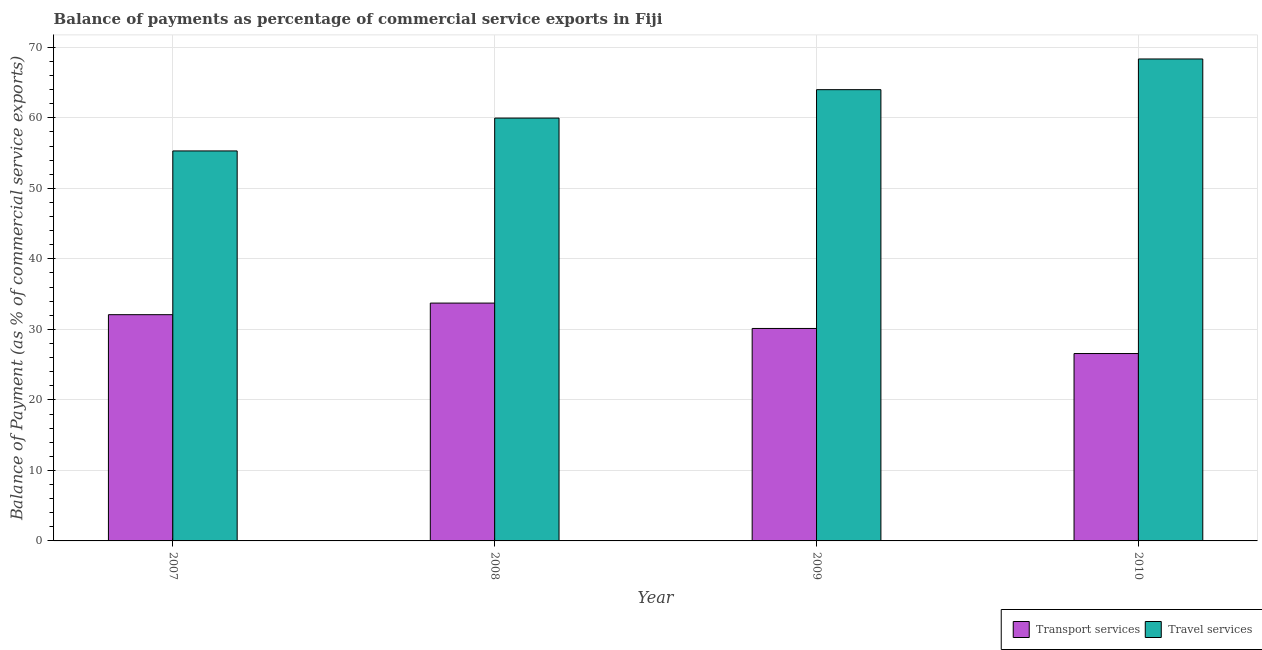How many groups of bars are there?
Your answer should be very brief. 4. Are the number of bars per tick equal to the number of legend labels?
Ensure brevity in your answer.  Yes. How many bars are there on the 3rd tick from the left?
Provide a succinct answer. 2. How many bars are there on the 3rd tick from the right?
Provide a succinct answer. 2. What is the balance of payments of travel services in 2009?
Offer a terse response. 64. Across all years, what is the maximum balance of payments of travel services?
Provide a short and direct response. 68.36. Across all years, what is the minimum balance of payments of transport services?
Give a very brief answer. 26.58. In which year was the balance of payments of travel services minimum?
Your answer should be very brief. 2007. What is the total balance of payments of travel services in the graph?
Your response must be concise. 247.64. What is the difference between the balance of payments of travel services in 2007 and that in 2009?
Keep it short and to the point. -8.69. What is the difference between the balance of payments of transport services in 2008 and the balance of payments of travel services in 2009?
Ensure brevity in your answer.  3.6. What is the average balance of payments of travel services per year?
Offer a very short reply. 61.91. What is the ratio of the balance of payments of travel services in 2008 to that in 2009?
Offer a terse response. 0.94. Is the difference between the balance of payments of transport services in 2009 and 2010 greater than the difference between the balance of payments of travel services in 2009 and 2010?
Offer a terse response. No. What is the difference between the highest and the second highest balance of payments of travel services?
Offer a terse response. 4.35. What is the difference between the highest and the lowest balance of payments of transport services?
Offer a very short reply. 7.16. In how many years, is the balance of payments of transport services greater than the average balance of payments of transport services taken over all years?
Your response must be concise. 2. What does the 2nd bar from the left in 2010 represents?
Your response must be concise. Travel services. What does the 2nd bar from the right in 2007 represents?
Your answer should be very brief. Transport services. How many years are there in the graph?
Keep it short and to the point. 4. Are the values on the major ticks of Y-axis written in scientific E-notation?
Give a very brief answer. No. Does the graph contain grids?
Your answer should be very brief. Yes. Where does the legend appear in the graph?
Make the answer very short. Bottom right. How many legend labels are there?
Your answer should be compact. 2. How are the legend labels stacked?
Ensure brevity in your answer.  Horizontal. What is the title of the graph?
Offer a terse response. Balance of payments as percentage of commercial service exports in Fiji. Does "Canada" appear as one of the legend labels in the graph?
Your answer should be very brief. No. What is the label or title of the X-axis?
Ensure brevity in your answer.  Year. What is the label or title of the Y-axis?
Your response must be concise. Balance of Payment (as % of commercial service exports). What is the Balance of Payment (as % of commercial service exports) in Transport services in 2007?
Your answer should be very brief. 32.09. What is the Balance of Payment (as % of commercial service exports) in Travel services in 2007?
Your response must be concise. 55.31. What is the Balance of Payment (as % of commercial service exports) in Transport services in 2008?
Make the answer very short. 33.73. What is the Balance of Payment (as % of commercial service exports) of Travel services in 2008?
Keep it short and to the point. 59.97. What is the Balance of Payment (as % of commercial service exports) of Transport services in 2009?
Give a very brief answer. 30.13. What is the Balance of Payment (as % of commercial service exports) in Travel services in 2009?
Provide a succinct answer. 64. What is the Balance of Payment (as % of commercial service exports) in Transport services in 2010?
Ensure brevity in your answer.  26.58. What is the Balance of Payment (as % of commercial service exports) in Travel services in 2010?
Ensure brevity in your answer.  68.36. Across all years, what is the maximum Balance of Payment (as % of commercial service exports) in Transport services?
Offer a terse response. 33.73. Across all years, what is the maximum Balance of Payment (as % of commercial service exports) of Travel services?
Your answer should be compact. 68.36. Across all years, what is the minimum Balance of Payment (as % of commercial service exports) of Transport services?
Keep it short and to the point. 26.58. Across all years, what is the minimum Balance of Payment (as % of commercial service exports) of Travel services?
Offer a very short reply. 55.31. What is the total Balance of Payment (as % of commercial service exports) of Transport services in the graph?
Ensure brevity in your answer.  122.53. What is the total Balance of Payment (as % of commercial service exports) of Travel services in the graph?
Give a very brief answer. 247.64. What is the difference between the Balance of Payment (as % of commercial service exports) of Transport services in 2007 and that in 2008?
Offer a terse response. -1.64. What is the difference between the Balance of Payment (as % of commercial service exports) of Travel services in 2007 and that in 2008?
Make the answer very short. -4.66. What is the difference between the Balance of Payment (as % of commercial service exports) of Transport services in 2007 and that in 2009?
Ensure brevity in your answer.  1.96. What is the difference between the Balance of Payment (as % of commercial service exports) of Travel services in 2007 and that in 2009?
Provide a short and direct response. -8.69. What is the difference between the Balance of Payment (as % of commercial service exports) of Transport services in 2007 and that in 2010?
Give a very brief answer. 5.51. What is the difference between the Balance of Payment (as % of commercial service exports) of Travel services in 2007 and that in 2010?
Provide a short and direct response. -13.04. What is the difference between the Balance of Payment (as % of commercial service exports) in Transport services in 2008 and that in 2009?
Offer a very short reply. 3.6. What is the difference between the Balance of Payment (as % of commercial service exports) in Travel services in 2008 and that in 2009?
Ensure brevity in your answer.  -4.03. What is the difference between the Balance of Payment (as % of commercial service exports) of Transport services in 2008 and that in 2010?
Provide a succinct answer. 7.16. What is the difference between the Balance of Payment (as % of commercial service exports) in Travel services in 2008 and that in 2010?
Offer a terse response. -8.38. What is the difference between the Balance of Payment (as % of commercial service exports) of Transport services in 2009 and that in 2010?
Make the answer very short. 3.56. What is the difference between the Balance of Payment (as % of commercial service exports) of Travel services in 2009 and that in 2010?
Keep it short and to the point. -4.35. What is the difference between the Balance of Payment (as % of commercial service exports) of Transport services in 2007 and the Balance of Payment (as % of commercial service exports) of Travel services in 2008?
Offer a very short reply. -27.88. What is the difference between the Balance of Payment (as % of commercial service exports) in Transport services in 2007 and the Balance of Payment (as % of commercial service exports) in Travel services in 2009?
Make the answer very short. -31.91. What is the difference between the Balance of Payment (as % of commercial service exports) in Transport services in 2007 and the Balance of Payment (as % of commercial service exports) in Travel services in 2010?
Provide a succinct answer. -36.27. What is the difference between the Balance of Payment (as % of commercial service exports) of Transport services in 2008 and the Balance of Payment (as % of commercial service exports) of Travel services in 2009?
Make the answer very short. -30.27. What is the difference between the Balance of Payment (as % of commercial service exports) of Transport services in 2008 and the Balance of Payment (as % of commercial service exports) of Travel services in 2010?
Make the answer very short. -34.62. What is the difference between the Balance of Payment (as % of commercial service exports) in Transport services in 2009 and the Balance of Payment (as % of commercial service exports) in Travel services in 2010?
Keep it short and to the point. -38.22. What is the average Balance of Payment (as % of commercial service exports) in Transport services per year?
Offer a terse response. 30.63. What is the average Balance of Payment (as % of commercial service exports) in Travel services per year?
Offer a terse response. 61.91. In the year 2007, what is the difference between the Balance of Payment (as % of commercial service exports) in Transport services and Balance of Payment (as % of commercial service exports) in Travel services?
Give a very brief answer. -23.22. In the year 2008, what is the difference between the Balance of Payment (as % of commercial service exports) in Transport services and Balance of Payment (as % of commercial service exports) in Travel services?
Offer a terse response. -26.24. In the year 2009, what is the difference between the Balance of Payment (as % of commercial service exports) of Transport services and Balance of Payment (as % of commercial service exports) of Travel services?
Ensure brevity in your answer.  -33.87. In the year 2010, what is the difference between the Balance of Payment (as % of commercial service exports) of Transport services and Balance of Payment (as % of commercial service exports) of Travel services?
Offer a terse response. -41.78. What is the ratio of the Balance of Payment (as % of commercial service exports) in Transport services in 2007 to that in 2008?
Keep it short and to the point. 0.95. What is the ratio of the Balance of Payment (as % of commercial service exports) of Travel services in 2007 to that in 2008?
Keep it short and to the point. 0.92. What is the ratio of the Balance of Payment (as % of commercial service exports) in Transport services in 2007 to that in 2009?
Make the answer very short. 1.06. What is the ratio of the Balance of Payment (as % of commercial service exports) of Travel services in 2007 to that in 2009?
Offer a very short reply. 0.86. What is the ratio of the Balance of Payment (as % of commercial service exports) in Transport services in 2007 to that in 2010?
Your response must be concise. 1.21. What is the ratio of the Balance of Payment (as % of commercial service exports) in Travel services in 2007 to that in 2010?
Make the answer very short. 0.81. What is the ratio of the Balance of Payment (as % of commercial service exports) of Transport services in 2008 to that in 2009?
Make the answer very short. 1.12. What is the ratio of the Balance of Payment (as % of commercial service exports) in Travel services in 2008 to that in 2009?
Provide a short and direct response. 0.94. What is the ratio of the Balance of Payment (as % of commercial service exports) in Transport services in 2008 to that in 2010?
Make the answer very short. 1.27. What is the ratio of the Balance of Payment (as % of commercial service exports) in Travel services in 2008 to that in 2010?
Provide a succinct answer. 0.88. What is the ratio of the Balance of Payment (as % of commercial service exports) of Transport services in 2009 to that in 2010?
Ensure brevity in your answer.  1.13. What is the ratio of the Balance of Payment (as % of commercial service exports) in Travel services in 2009 to that in 2010?
Make the answer very short. 0.94. What is the difference between the highest and the second highest Balance of Payment (as % of commercial service exports) in Transport services?
Keep it short and to the point. 1.64. What is the difference between the highest and the second highest Balance of Payment (as % of commercial service exports) of Travel services?
Keep it short and to the point. 4.35. What is the difference between the highest and the lowest Balance of Payment (as % of commercial service exports) of Transport services?
Offer a terse response. 7.16. What is the difference between the highest and the lowest Balance of Payment (as % of commercial service exports) of Travel services?
Offer a very short reply. 13.04. 